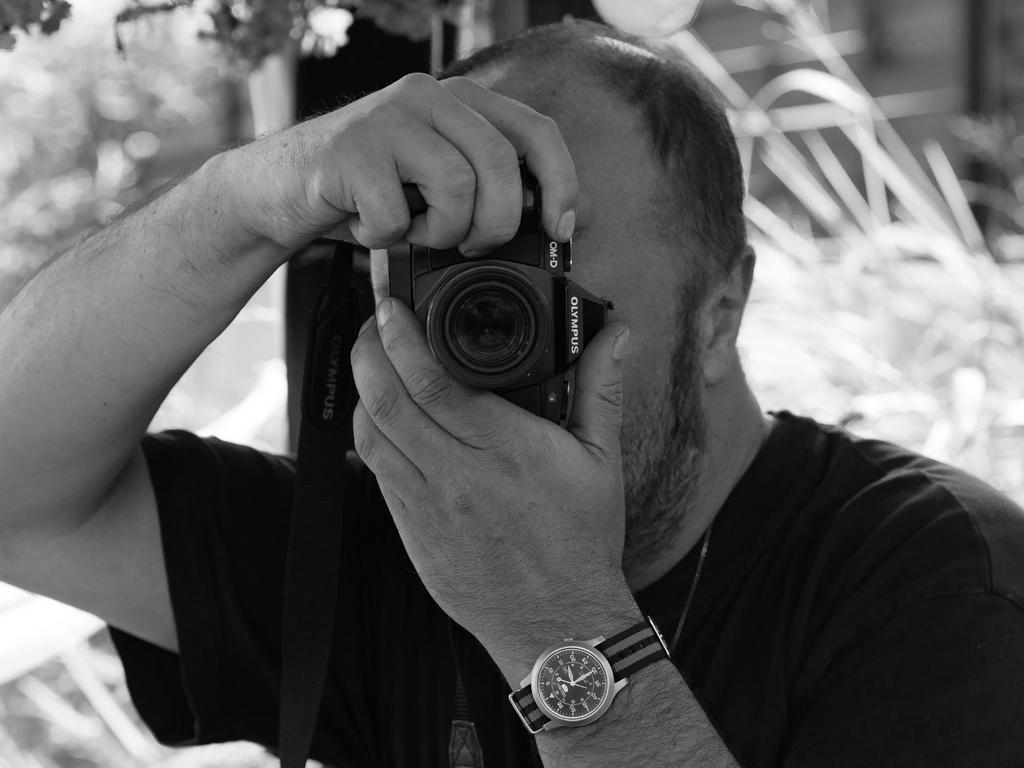Who is the main subject in the image? There is a man in the center of the image. What is the man holding in the image? The man is holding a camera. What can be seen in the background of the image? There are trees visible in the background of the image. What type of argument is taking place between the snakes in the image? There are no snakes present in the image, so it is not possible to determine if an argument is taking place. 